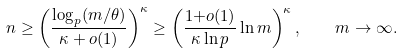Convert formula to latex. <formula><loc_0><loc_0><loc_500><loc_500>n \geq \left ( \frac { \log _ { p } ( m / \theta ) } { \kappa + o ( 1 ) } \right ) ^ { \kappa } \geq \left ( \frac { 1 { + } o ( 1 ) } { \kappa \ln p } \ln m \right ) ^ { \kappa } , \quad m \to \infty .</formula> 